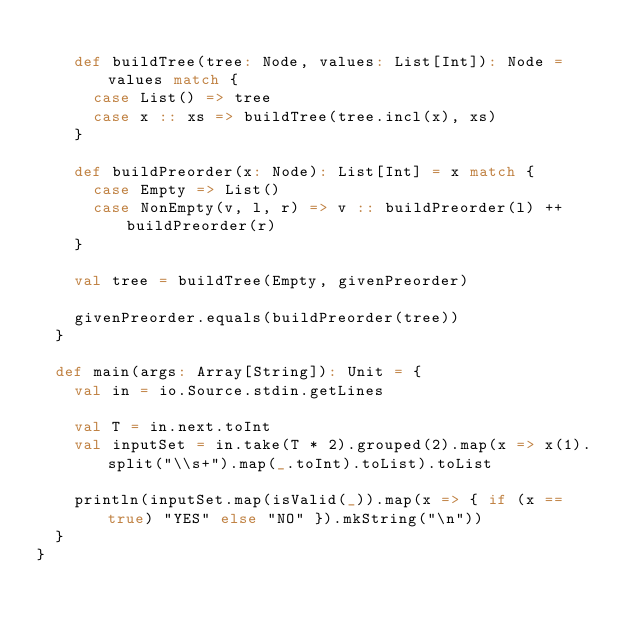Convert code to text. <code><loc_0><loc_0><loc_500><loc_500><_Scala_>
    def buildTree(tree: Node, values: List[Int]): Node = values match {
      case List() => tree
      case x :: xs => buildTree(tree.incl(x), xs)
    }
    
    def buildPreorder(x: Node): List[Int] = x match {
      case Empty => List()
      case NonEmpty(v, l, r) => v :: buildPreorder(l) ++ buildPreorder(r)   
    }

    val tree = buildTree(Empty, givenPreorder)
    
    givenPreorder.equals(buildPreorder(tree))
  }

  def main(args: Array[String]): Unit = {
    val in = io.Source.stdin.getLines

    val T = in.next.toInt
    val inputSet = in.take(T * 2).grouped(2).map(x => x(1).split("\\s+").map(_.toInt).toList).toList
    
    println(inputSet.map(isValid(_)).map(x => { if (x == true) "YES" else "NO" }).mkString("\n"))
  }
}</code> 